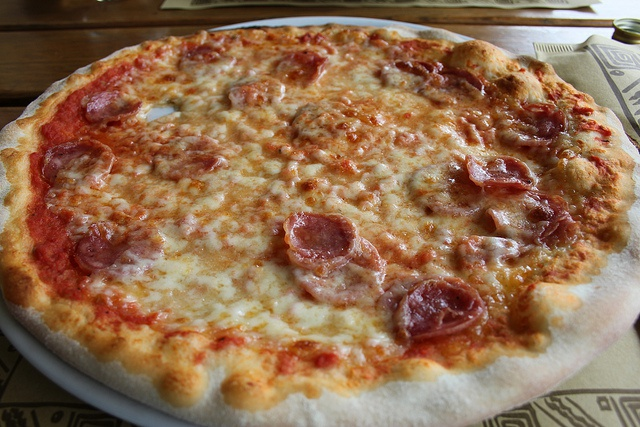Describe the objects in this image and their specific colors. I can see a pizza in black, brown, tan, maroon, and darkgray tones in this image. 